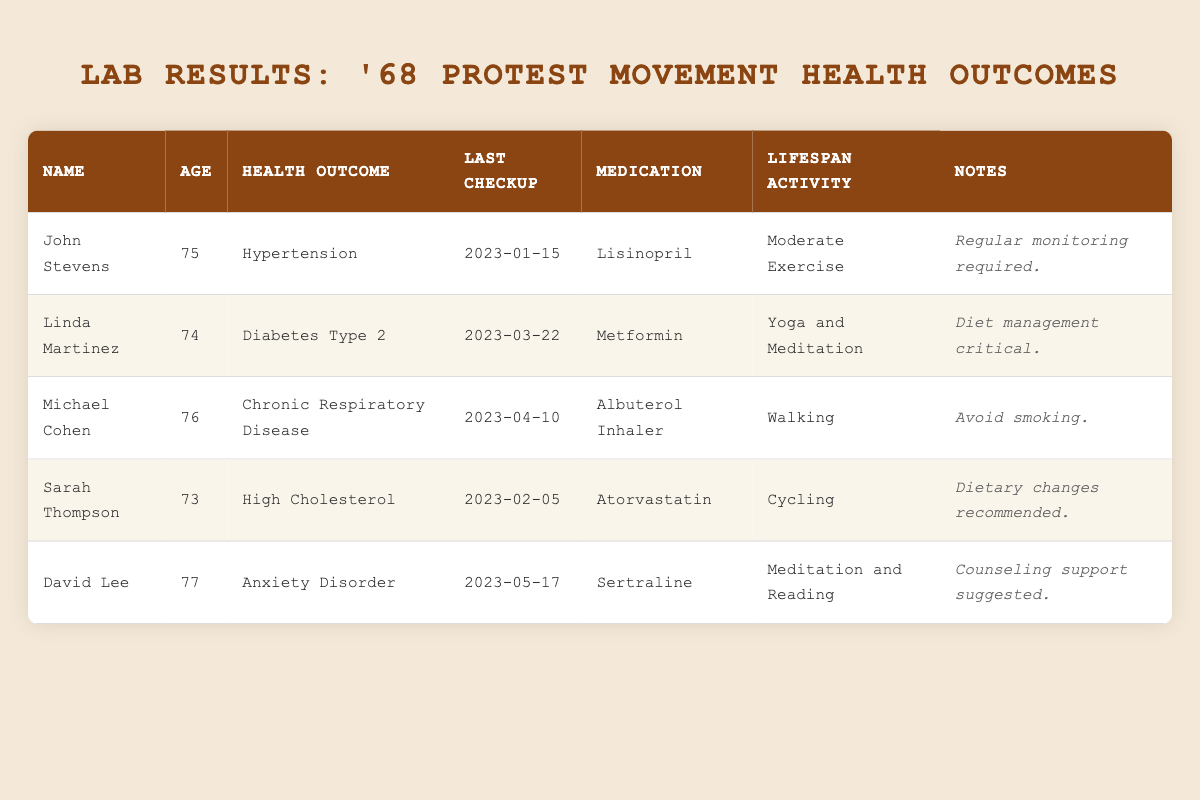What health outcome does John Stevens have? According to the table, the "Health Outcome" column shows that John Stevens has Hypertension.
Answer: Hypertension When was Linda Martinez's last checkup? Looking at the "Last Checkup" column for Linda Martinez, it was on March 22, 2023.
Answer: March 22, 2023 How many individuals are reported to have Chronic Respiratory Disease? By reviewing the table, it shows that only one individual, Michael Cohen, is reported to have Chronic Respiratory Disease.
Answer: One What is the average age of the former activists listed? The ages provided are 75, 74, 76, 73, and 77. Adding these gives 375. There are 5 individuals, so the average age is 375/5 = 75.
Answer: 75 Does Sarah Thompson take medication for anxiety? Checking the "Medication" information for Sarah Thompson, she takes Atorvastatin, which is for high cholesterol, not anxiety. Therefore, the answer is no.
Answer: No Which age group has the highest health complexity based on the number of health outcomes? The table lists various health outcomes and their respective ages. Upon examining the health conditions, David Lee has an Anxiety Disorder which suggests a more complex health outcome. This aligns with his age of 77 being the oldest individual on the list.
Answer: 77 Is Michael Cohen's lifespan activity listed as yoga? The table indicates Michael Cohen's lifespan activity as Walking, not Yoga. Therefore, the answer is no.
Answer: No What is the most common medication among the former activists? Looking through the "Medication" column, Lisinopril (John Stevens), Metformin (Linda Martinez), Albuterol Inhaler (Michael Cohen), Atorvastatin (Sarah Thompson), and Sertraline (David Lee) are listed. None are repeated. Thus, there is no common medication.
Answer: None How many individuals are actively participating in exercise-related activities? Upon inspecting the "Lifespan Activity" column, four individuals, John Stevens, Linda Martinez, Michael Cohen, and Sarah Thompson, engage in exercise, while only David Lee practices meditation which is less exercise-oriented. Counting these gives a total of four individuals engaging in physical activity.
Answer: Four 